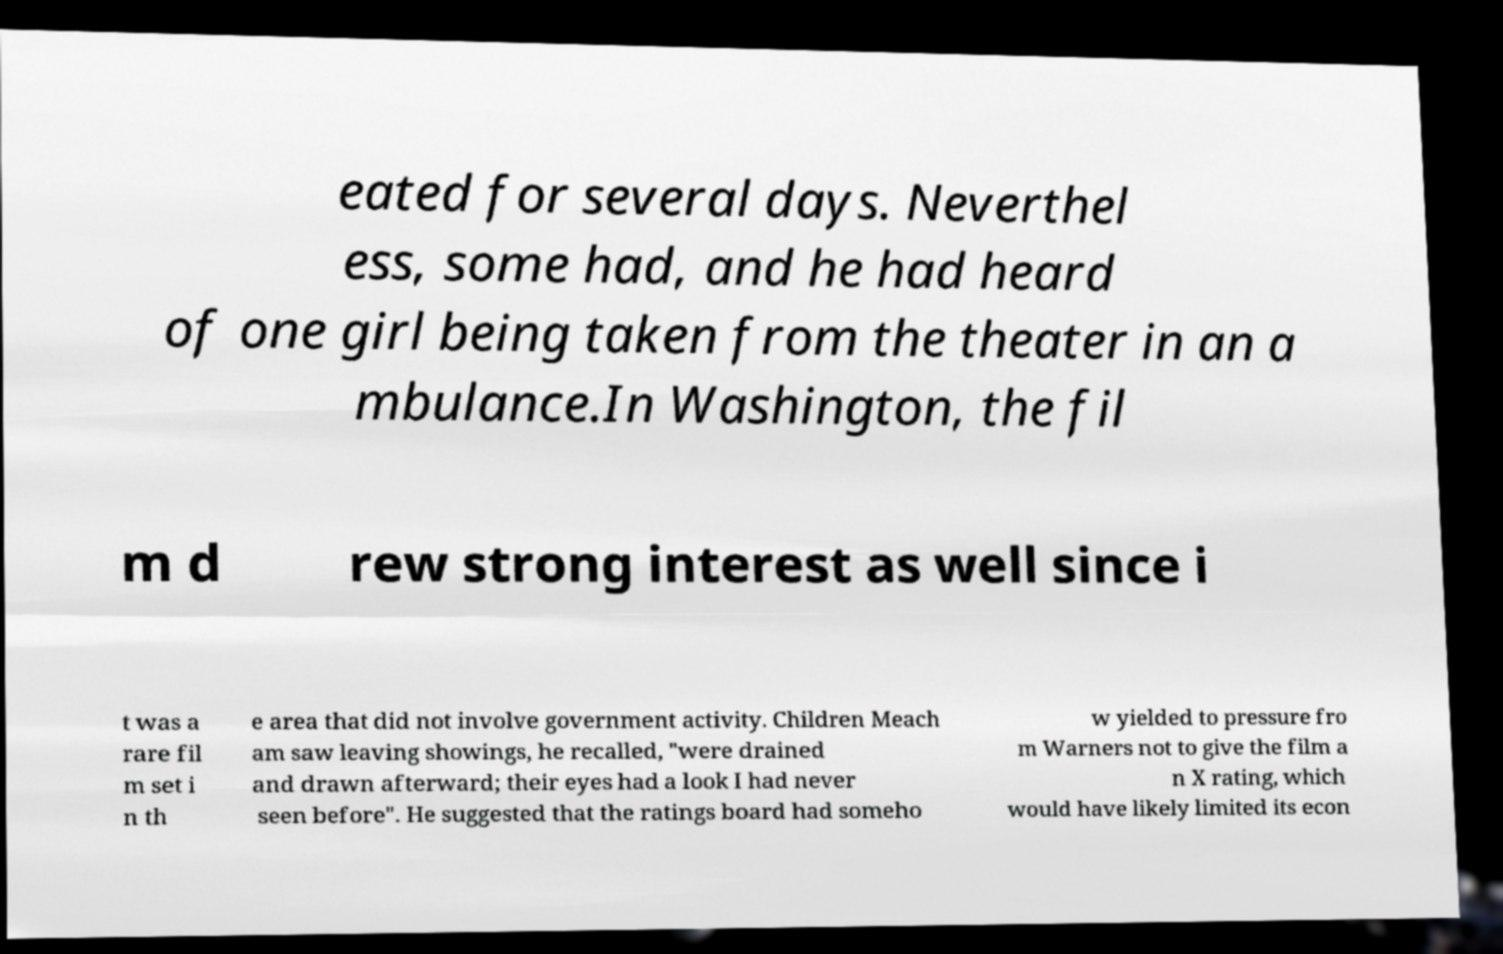Could you assist in decoding the text presented in this image and type it out clearly? eated for several days. Neverthel ess, some had, and he had heard of one girl being taken from the theater in an a mbulance.In Washington, the fil m d rew strong interest as well since i t was a rare fil m set i n th e area that did not involve government activity. Children Meach am saw leaving showings, he recalled, "were drained and drawn afterward; their eyes had a look I had never seen before". He suggested that the ratings board had someho w yielded to pressure fro m Warners not to give the film a n X rating, which would have likely limited its econ 